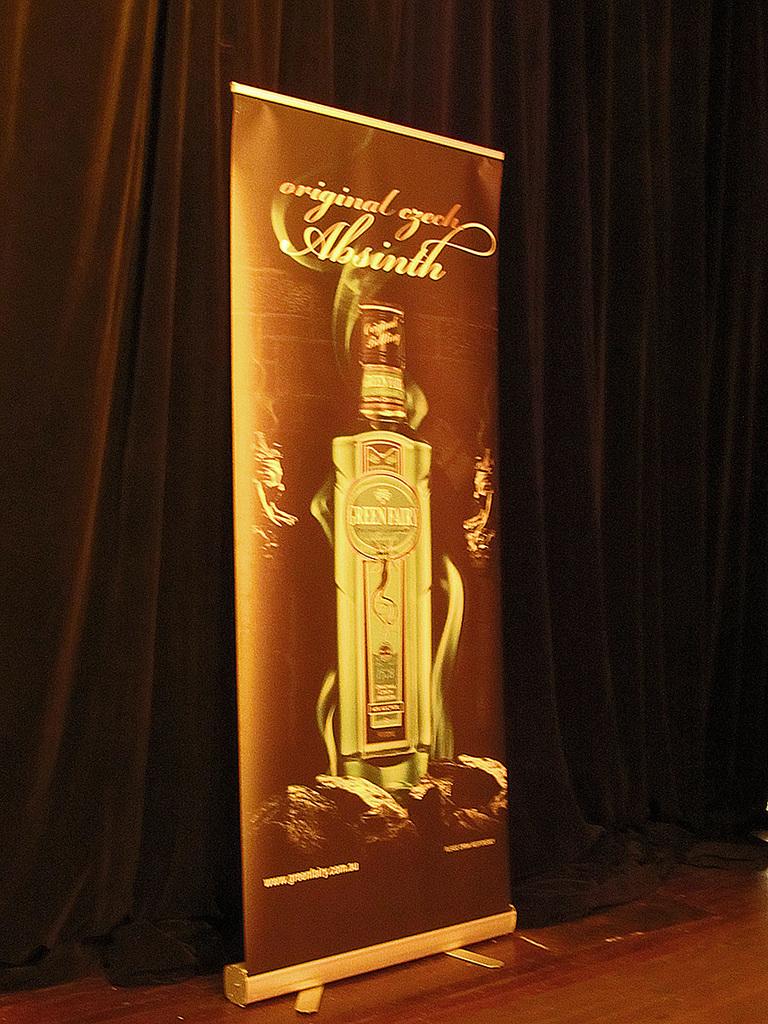What is the name on the poster?
Make the answer very short. Absinth. 